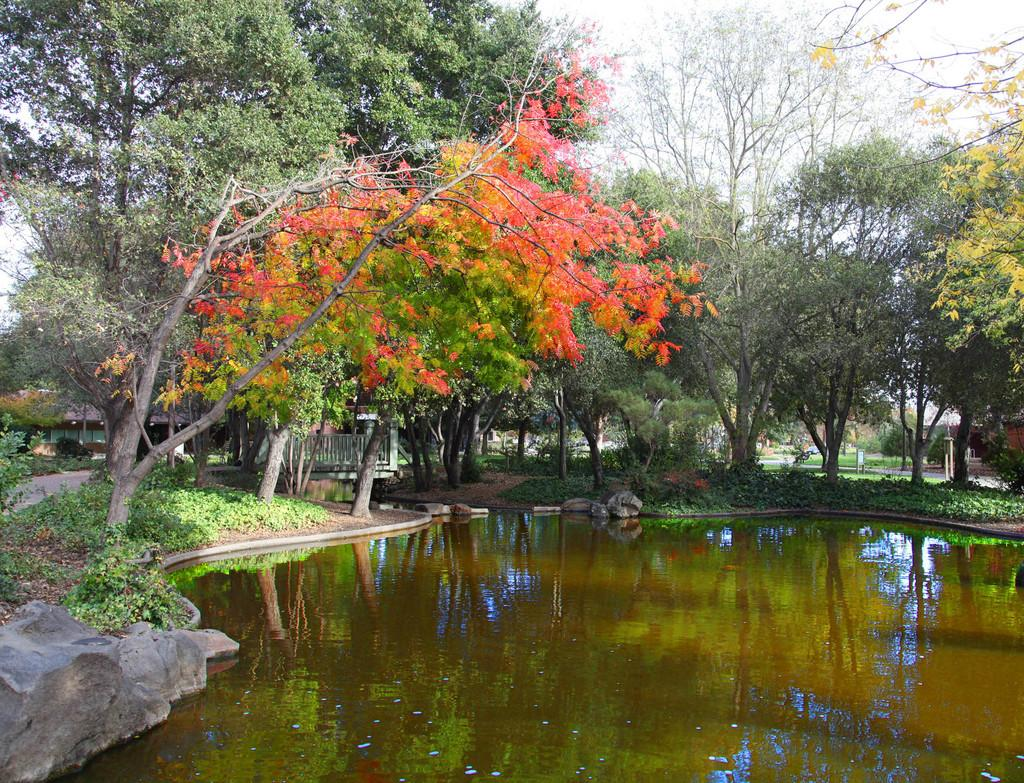What type of body of water is present in the image? There is a lake in the image. What type of terrain can be seen near the lake? There are stones, grass, and trees visible in the image. What type of structure is present near the lake? There is a shed in the image. What type of cooking equipment is present in the image? There are wooden grills in the image. What type of man-made structures can be seen in the image? There are buildings in the image. What part of the natural environment is visible in the image? The sky is visible in the image. What type of knife is being used to cut the bone in the image? There is no knife or bone present in the image. 